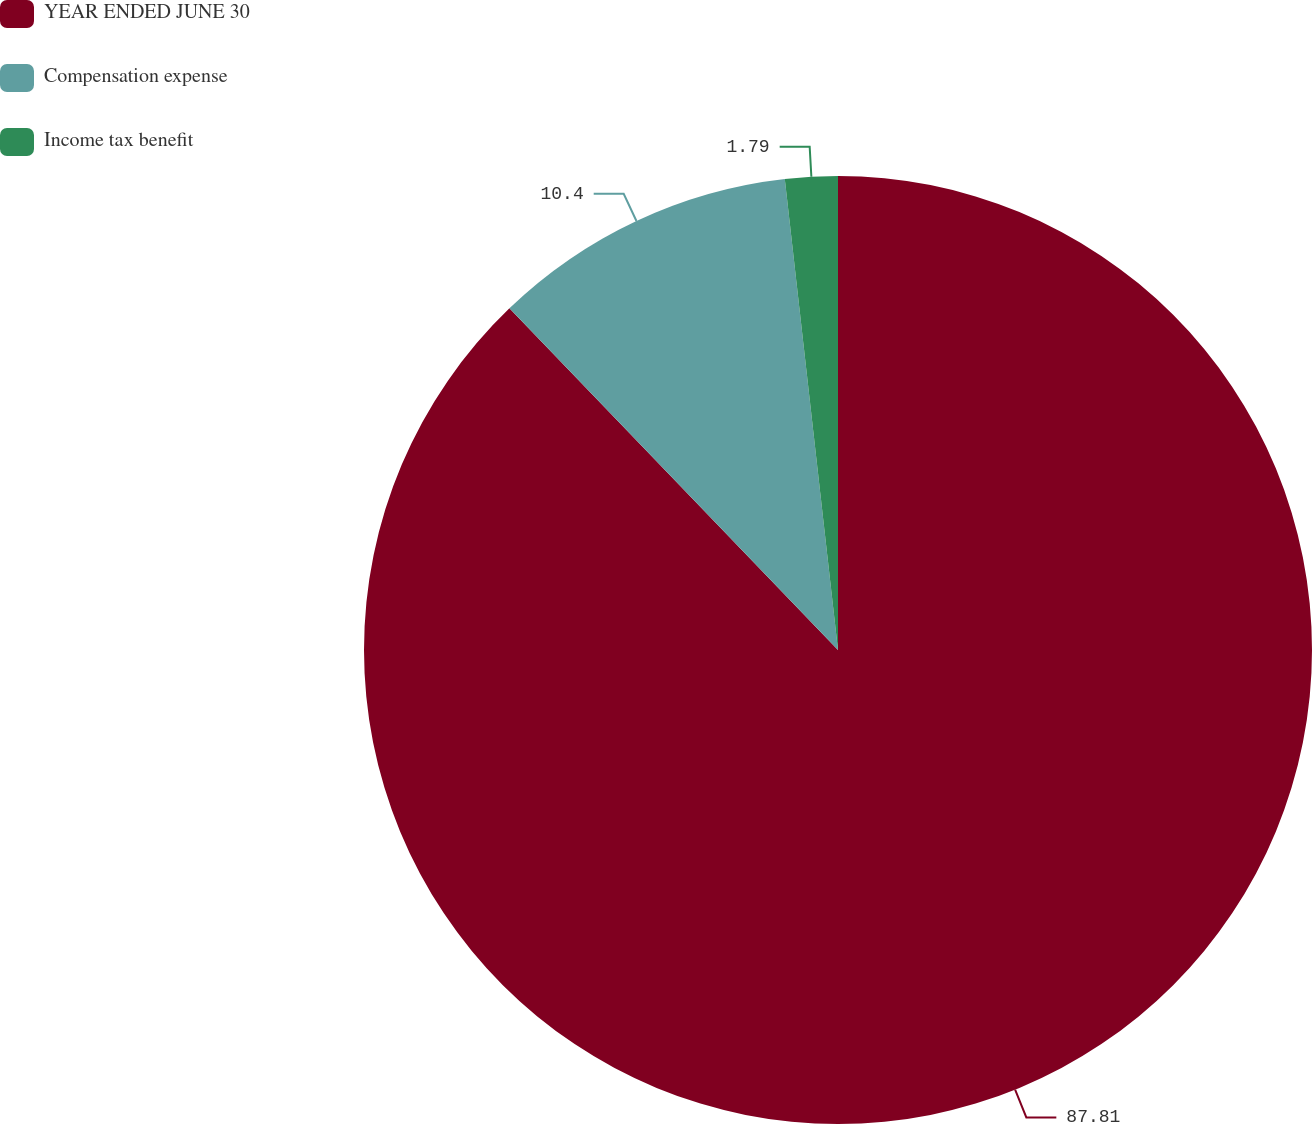Convert chart to OTSL. <chart><loc_0><loc_0><loc_500><loc_500><pie_chart><fcel>YEAR ENDED JUNE 30<fcel>Compensation expense<fcel>Income tax benefit<nl><fcel>87.81%<fcel>10.4%<fcel>1.79%<nl></chart> 